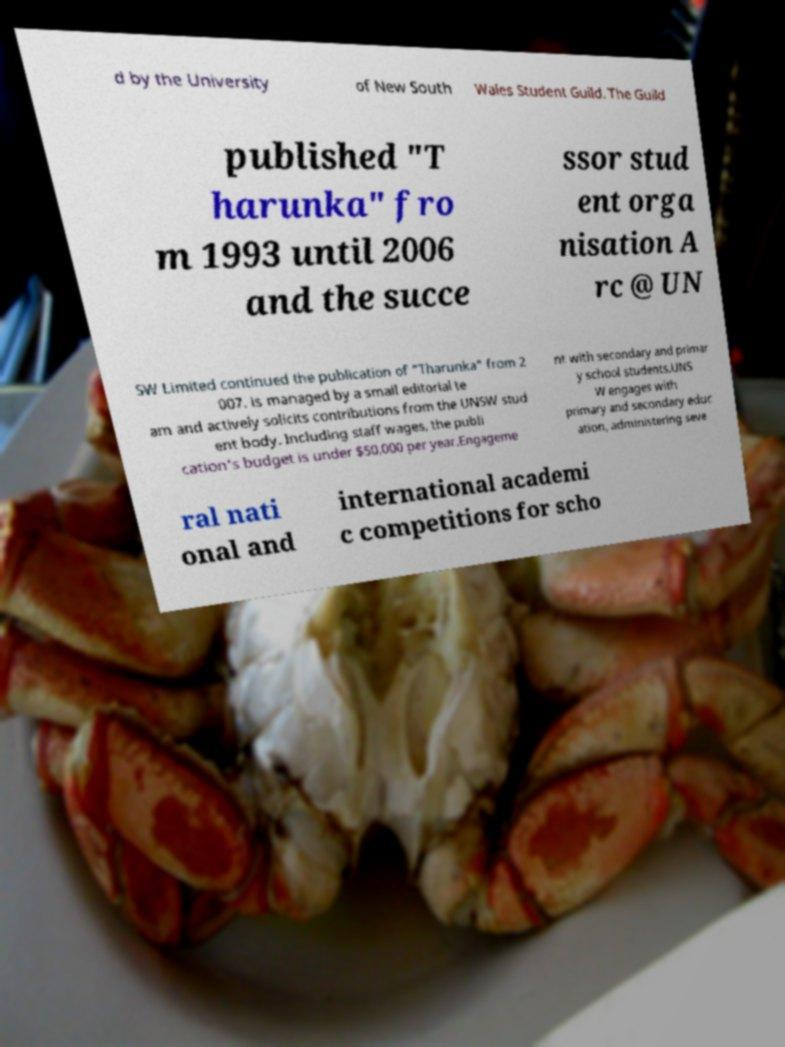Can you accurately transcribe the text from the provided image for me? d by the University of New South Wales Student Guild. The Guild published "T harunka" fro m 1993 until 2006 and the succe ssor stud ent orga nisation A rc @ UN SW Limited continued the publication of "Tharunka" from 2 007. is managed by a small editorial te am and actively solicits contributions from the UNSW stud ent body. Including staff wages, the publi cation's budget is under $50,000 per year.Engageme nt with secondary and primar y school students.UNS W engages with primary and secondary educ ation, administering seve ral nati onal and international academi c competitions for scho 